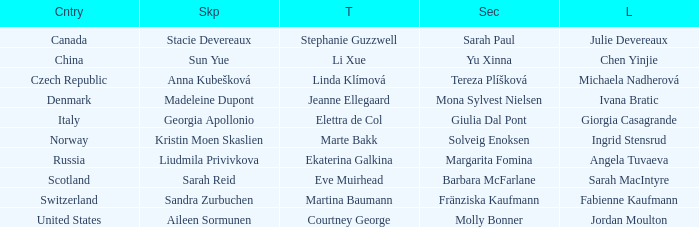What skip has martina baumann as the third? Sandra Zurbuchen. 